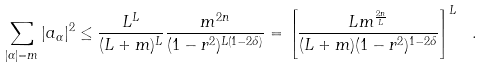Convert formula to latex. <formula><loc_0><loc_0><loc_500><loc_500>\sum _ { | \alpha | = m } | a _ { \alpha } | ^ { 2 } \leq \frac { L ^ { L } } { ( L + m ) ^ { L } } \frac { m ^ { 2 n } } { ( 1 - r ^ { 2 } ) ^ { L ( 1 - 2 \delta ) } } = \left [ \frac { L m ^ { \frac { 2 n } L } } { ( L + m ) ( 1 - r ^ { 2 } ) ^ { 1 - 2 \delta } } \right ] ^ { L } \ .</formula> 